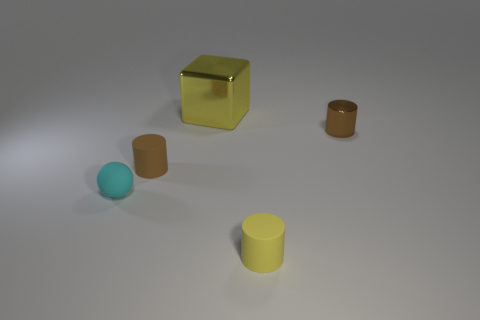Is there a brown cylinder of the same size as the matte ball?
Ensure brevity in your answer.  Yes. There is a brown metallic object; is it the same size as the yellow thing behind the rubber sphere?
Provide a short and direct response. No. Are there an equal number of cyan matte balls to the right of the small rubber sphere and shiny things to the left of the large yellow shiny cube?
Give a very brief answer. Yes. What shape is the object that is the same color as the metallic block?
Keep it short and to the point. Cylinder. What material is the small brown cylinder on the left side of the brown metallic cylinder?
Your answer should be compact. Rubber. Do the yellow matte object and the cyan rubber ball have the same size?
Make the answer very short. Yes. Are there more matte cylinders to the right of the large yellow block than red metal cylinders?
Provide a short and direct response. Yes. There is a large yellow metal block; are there any yellow objects in front of it?
Provide a short and direct response. Yes. Is the tiny yellow thing the same shape as the brown matte object?
Ensure brevity in your answer.  Yes. There is a yellow thing behind the tiny brown cylinder that is left of the tiny rubber cylinder that is on the right side of the yellow metallic object; what size is it?
Keep it short and to the point. Large. 